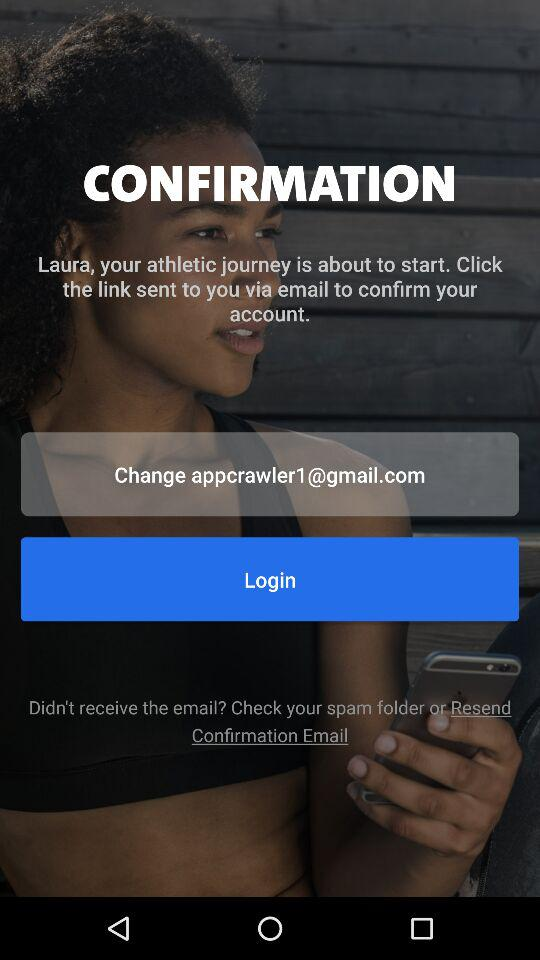What email address is used for logging? The email address used for logging is appcrawler1@gmail.com. 